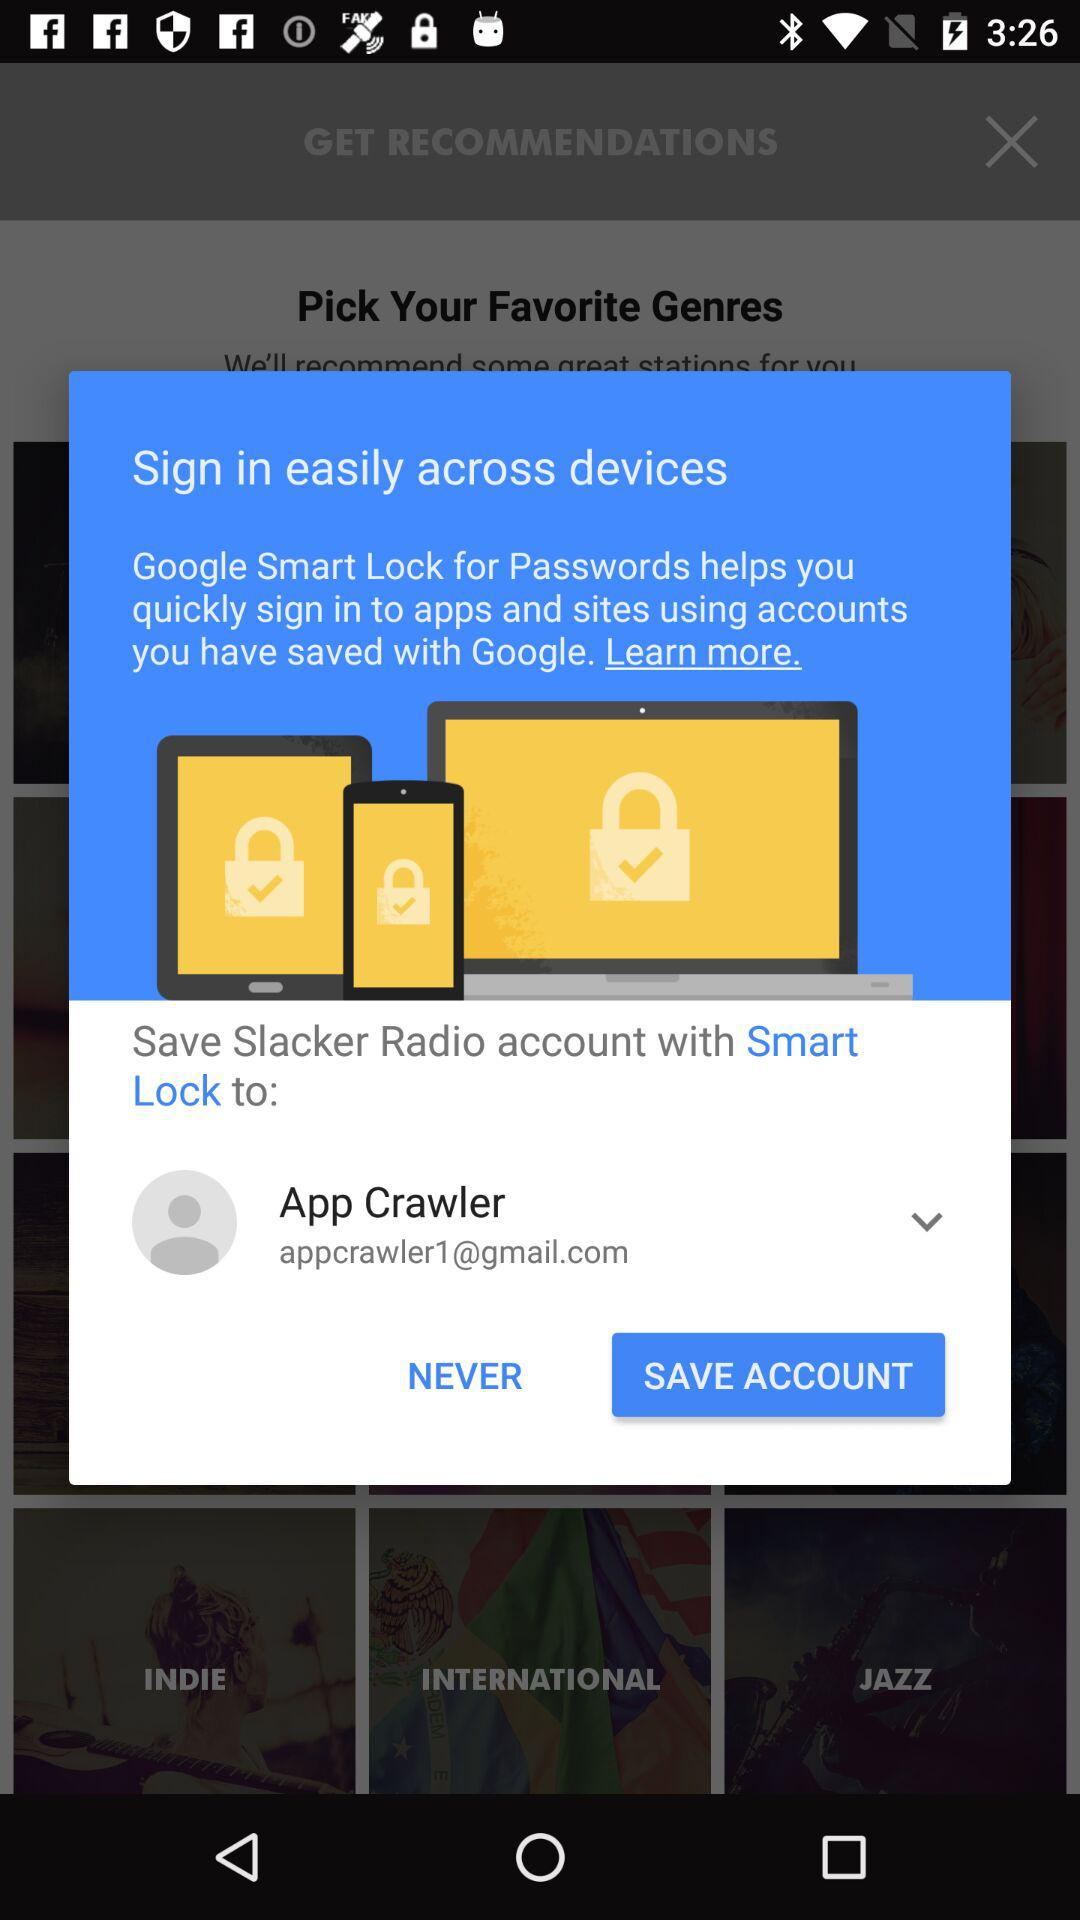How many devices are associated with this Google Smart Lock account?
Answer the question using a single word or phrase. 3 